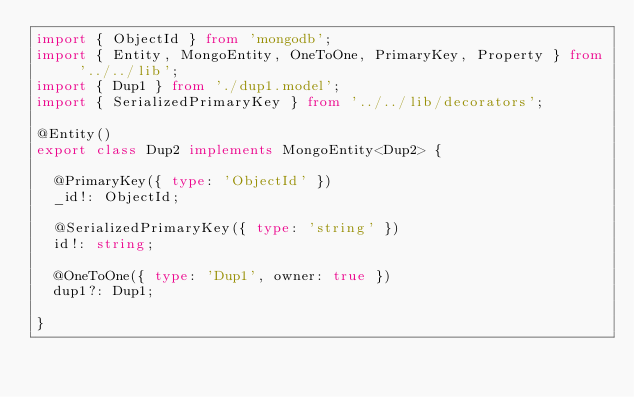<code> <loc_0><loc_0><loc_500><loc_500><_TypeScript_>import { ObjectId } from 'mongodb';
import { Entity, MongoEntity, OneToOne, PrimaryKey, Property } from '../../lib';
import { Dup1 } from './dup1.model';
import { SerializedPrimaryKey } from '../../lib/decorators';

@Entity()
export class Dup2 implements MongoEntity<Dup2> {

  @PrimaryKey({ type: 'ObjectId' })
  _id!: ObjectId;

  @SerializedPrimaryKey({ type: 'string' })
  id!: string;

  @OneToOne({ type: 'Dup1', owner: true })
  dup1?: Dup1;

}
</code> 